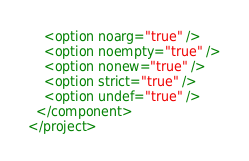Convert code to text. <code><loc_0><loc_0><loc_500><loc_500><_XML_>    <option noarg="true" />
    <option noempty="true" />
    <option nonew="true" />
    <option strict="true" />
    <option undef="true" />
  </component>
</project></code> 